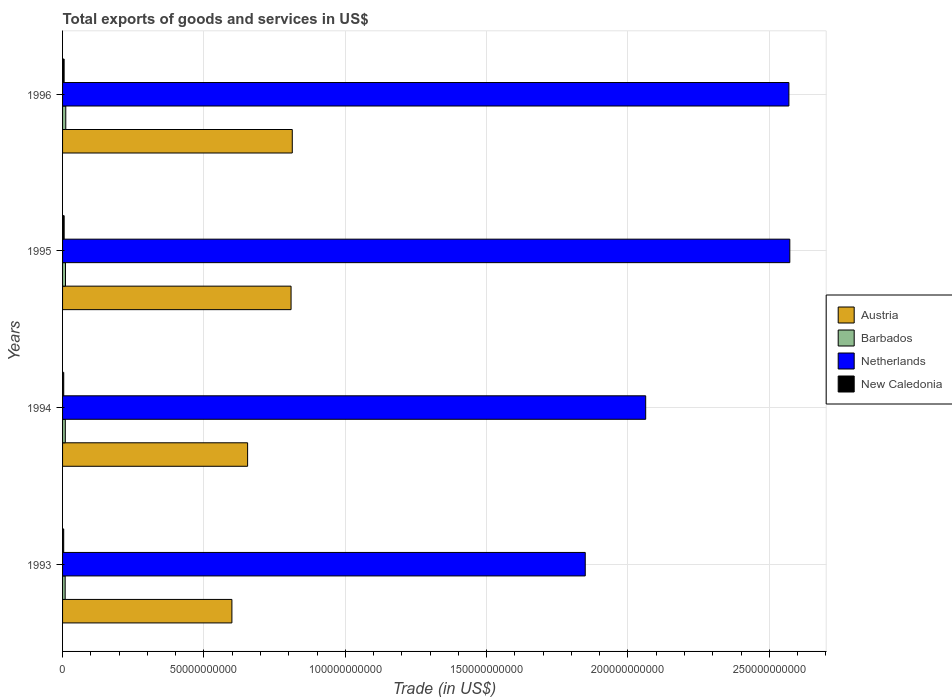Are the number of bars on each tick of the Y-axis equal?
Offer a terse response. Yes. How many bars are there on the 3rd tick from the top?
Your answer should be very brief. 4. What is the label of the 2nd group of bars from the top?
Make the answer very short. 1995. In how many cases, is the number of bars for a given year not equal to the number of legend labels?
Offer a terse response. 0. What is the total exports of goods and services in Netherlands in 1993?
Provide a succinct answer. 1.85e+11. Across all years, what is the maximum total exports of goods and services in Barbados?
Provide a short and direct response. 1.13e+09. Across all years, what is the minimum total exports of goods and services in New Caledonia?
Your answer should be very brief. 4.03e+08. In which year was the total exports of goods and services in New Caledonia maximum?
Your answer should be compact. 1995. In which year was the total exports of goods and services in Netherlands minimum?
Your response must be concise. 1993. What is the total total exports of goods and services in Austria in the graph?
Ensure brevity in your answer.  2.87e+11. What is the difference between the total exports of goods and services in Barbados in 1993 and that in 1995?
Provide a succinct answer. -1.16e+08. What is the difference between the total exports of goods and services in Austria in 1996 and the total exports of goods and services in New Caledonia in 1995?
Your response must be concise. 8.07e+1. What is the average total exports of goods and services in Netherlands per year?
Keep it short and to the point. 2.26e+11. In the year 1996, what is the difference between the total exports of goods and services in Barbados and total exports of goods and services in Austria?
Make the answer very short. -8.01e+1. In how many years, is the total exports of goods and services in Netherlands greater than 20000000000 US$?
Provide a short and direct response. 4. What is the ratio of the total exports of goods and services in New Caledonia in 1994 to that in 1995?
Keep it short and to the point. 0.73. Is the total exports of goods and services in Netherlands in 1993 less than that in 1996?
Your answer should be very brief. Yes. Is the difference between the total exports of goods and services in Barbados in 1994 and 1995 greater than the difference between the total exports of goods and services in Austria in 1994 and 1995?
Offer a terse response. Yes. What is the difference between the highest and the second highest total exports of goods and services in Austria?
Give a very brief answer. 4.29e+08. What is the difference between the highest and the lowest total exports of goods and services in Austria?
Provide a short and direct response. 2.14e+1. In how many years, is the total exports of goods and services in New Caledonia greater than the average total exports of goods and services in New Caledonia taken over all years?
Provide a succinct answer. 2. What does the 1st bar from the top in 1996 represents?
Offer a very short reply. New Caledonia. What does the 2nd bar from the bottom in 1994 represents?
Offer a very short reply. Barbados. How many bars are there?
Your response must be concise. 16. Are all the bars in the graph horizontal?
Your answer should be compact. Yes. How many years are there in the graph?
Your answer should be very brief. 4. Are the values on the major ticks of X-axis written in scientific E-notation?
Your response must be concise. No. Does the graph contain any zero values?
Offer a terse response. No. What is the title of the graph?
Offer a terse response. Total exports of goods and services in US$. What is the label or title of the X-axis?
Give a very brief answer. Trade (in US$). What is the Trade (in US$) in Austria in 1993?
Ensure brevity in your answer.  5.99e+1. What is the Trade (in US$) in Barbados in 1993?
Ensure brevity in your answer.  9.23e+08. What is the Trade (in US$) of Netherlands in 1993?
Make the answer very short. 1.85e+11. What is the Trade (in US$) in New Caledonia in 1993?
Your answer should be very brief. 4.03e+08. What is the Trade (in US$) in Austria in 1994?
Give a very brief answer. 6.55e+1. What is the Trade (in US$) of Barbados in 1994?
Provide a succinct answer. 9.73e+08. What is the Trade (in US$) of Netherlands in 1994?
Make the answer very short. 2.06e+11. What is the Trade (in US$) in New Caledonia in 1994?
Offer a very short reply. 4.13e+08. What is the Trade (in US$) in Austria in 1995?
Your answer should be very brief. 8.08e+1. What is the Trade (in US$) in Barbados in 1995?
Keep it short and to the point. 1.04e+09. What is the Trade (in US$) of Netherlands in 1995?
Your response must be concise. 2.57e+11. What is the Trade (in US$) of New Caledonia in 1995?
Your answer should be compact. 5.65e+08. What is the Trade (in US$) in Austria in 1996?
Your answer should be compact. 8.13e+1. What is the Trade (in US$) in Barbados in 1996?
Your response must be concise. 1.13e+09. What is the Trade (in US$) of Netherlands in 1996?
Your response must be concise. 2.57e+11. What is the Trade (in US$) of New Caledonia in 1996?
Your response must be concise. 5.54e+08. Across all years, what is the maximum Trade (in US$) in Austria?
Your answer should be compact. 8.13e+1. Across all years, what is the maximum Trade (in US$) of Barbados?
Your response must be concise. 1.13e+09. Across all years, what is the maximum Trade (in US$) in Netherlands?
Provide a succinct answer. 2.57e+11. Across all years, what is the maximum Trade (in US$) of New Caledonia?
Your answer should be compact. 5.65e+08. Across all years, what is the minimum Trade (in US$) of Austria?
Provide a succinct answer. 5.99e+1. Across all years, what is the minimum Trade (in US$) of Barbados?
Offer a very short reply. 9.23e+08. Across all years, what is the minimum Trade (in US$) of Netherlands?
Your response must be concise. 1.85e+11. Across all years, what is the minimum Trade (in US$) in New Caledonia?
Your answer should be compact. 4.03e+08. What is the total Trade (in US$) in Austria in the graph?
Offer a terse response. 2.87e+11. What is the total Trade (in US$) in Barbados in the graph?
Provide a short and direct response. 4.07e+09. What is the total Trade (in US$) in Netherlands in the graph?
Provide a succinct answer. 9.05e+11. What is the total Trade (in US$) of New Caledonia in the graph?
Your answer should be compact. 1.93e+09. What is the difference between the Trade (in US$) in Austria in 1993 and that in 1994?
Your response must be concise. -5.55e+09. What is the difference between the Trade (in US$) of Barbados in 1993 and that in 1994?
Make the answer very short. -5.02e+07. What is the difference between the Trade (in US$) in Netherlands in 1993 and that in 1994?
Your response must be concise. -2.14e+1. What is the difference between the Trade (in US$) of New Caledonia in 1993 and that in 1994?
Ensure brevity in your answer.  -1.06e+07. What is the difference between the Trade (in US$) of Austria in 1993 and that in 1995?
Make the answer very short. -2.09e+1. What is the difference between the Trade (in US$) of Barbados in 1993 and that in 1995?
Keep it short and to the point. -1.16e+08. What is the difference between the Trade (in US$) of Netherlands in 1993 and that in 1995?
Keep it short and to the point. -7.24e+1. What is the difference between the Trade (in US$) of New Caledonia in 1993 and that in 1995?
Offer a very short reply. -1.62e+08. What is the difference between the Trade (in US$) of Austria in 1993 and that in 1996?
Your answer should be very brief. -2.14e+1. What is the difference between the Trade (in US$) of Barbados in 1993 and that in 1996?
Give a very brief answer. -2.11e+08. What is the difference between the Trade (in US$) of Netherlands in 1993 and that in 1996?
Provide a succinct answer. -7.20e+1. What is the difference between the Trade (in US$) of New Caledonia in 1993 and that in 1996?
Ensure brevity in your answer.  -1.51e+08. What is the difference between the Trade (in US$) in Austria in 1994 and that in 1995?
Make the answer very short. -1.54e+1. What is the difference between the Trade (in US$) in Barbados in 1994 and that in 1995?
Your answer should be very brief. -6.56e+07. What is the difference between the Trade (in US$) of Netherlands in 1994 and that in 1995?
Provide a succinct answer. -5.10e+1. What is the difference between the Trade (in US$) of New Caledonia in 1994 and that in 1995?
Provide a short and direct response. -1.52e+08. What is the difference between the Trade (in US$) of Austria in 1994 and that in 1996?
Provide a succinct answer. -1.58e+1. What is the difference between the Trade (in US$) in Barbados in 1994 and that in 1996?
Make the answer very short. -1.61e+08. What is the difference between the Trade (in US$) of Netherlands in 1994 and that in 1996?
Keep it short and to the point. -5.07e+1. What is the difference between the Trade (in US$) in New Caledonia in 1994 and that in 1996?
Your response must be concise. -1.40e+08. What is the difference between the Trade (in US$) of Austria in 1995 and that in 1996?
Your response must be concise. -4.29e+08. What is the difference between the Trade (in US$) of Barbados in 1995 and that in 1996?
Make the answer very short. -9.55e+07. What is the difference between the Trade (in US$) of Netherlands in 1995 and that in 1996?
Your response must be concise. 3.20e+08. What is the difference between the Trade (in US$) in New Caledonia in 1995 and that in 1996?
Make the answer very short. 1.12e+07. What is the difference between the Trade (in US$) in Austria in 1993 and the Trade (in US$) in Barbados in 1994?
Offer a terse response. 5.89e+1. What is the difference between the Trade (in US$) of Austria in 1993 and the Trade (in US$) of Netherlands in 1994?
Provide a short and direct response. -1.46e+11. What is the difference between the Trade (in US$) of Austria in 1993 and the Trade (in US$) of New Caledonia in 1994?
Give a very brief answer. 5.95e+1. What is the difference between the Trade (in US$) of Barbados in 1993 and the Trade (in US$) of Netherlands in 1994?
Provide a succinct answer. -2.05e+11. What is the difference between the Trade (in US$) of Barbados in 1993 and the Trade (in US$) of New Caledonia in 1994?
Give a very brief answer. 5.10e+08. What is the difference between the Trade (in US$) of Netherlands in 1993 and the Trade (in US$) of New Caledonia in 1994?
Your answer should be very brief. 1.84e+11. What is the difference between the Trade (in US$) of Austria in 1993 and the Trade (in US$) of Barbados in 1995?
Give a very brief answer. 5.89e+1. What is the difference between the Trade (in US$) of Austria in 1993 and the Trade (in US$) of Netherlands in 1995?
Your answer should be compact. -1.97e+11. What is the difference between the Trade (in US$) of Austria in 1993 and the Trade (in US$) of New Caledonia in 1995?
Offer a terse response. 5.93e+1. What is the difference between the Trade (in US$) in Barbados in 1993 and the Trade (in US$) in Netherlands in 1995?
Provide a succinct answer. -2.56e+11. What is the difference between the Trade (in US$) in Barbados in 1993 and the Trade (in US$) in New Caledonia in 1995?
Keep it short and to the point. 3.59e+08. What is the difference between the Trade (in US$) in Netherlands in 1993 and the Trade (in US$) in New Caledonia in 1995?
Your answer should be very brief. 1.84e+11. What is the difference between the Trade (in US$) of Austria in 1993 and the Trade (in US$) of Barbados in 1996?
Your answer should be compact. 5.88e+1. What is the difference between the Trade (in US$) of Austria in 1993 and the Trade (in US$) of Netherlands in 1996?
Provide a short and direct response. -1.97e+11. What is the difference between the Trade (in US$) of Austria in 1993 and the Trade (in US$) of New Caledonia in 1996?
Give a very brief answer. 5.93e+1. What is the difference between the Trade (in US$) of Barbados in 1993 and the Trade (in US$) of Netherlands in 1996?
Ensure brevity in your answer.  -2.56e+11. What is the difference between the Trade (in US$) of Barbados in 1993 and the Trade (in US$) of New Caledonia in 1996?
Keep it short and to the point. 3.70e+08. What is the difference between the Trade (in US$) in Netherlands in 1993 and the Trade (in US$) in New Caledonia in 1996?
Offer a very short reply. 1.84e+11. What is the difference between the Trade (in US$) in Austria in 1994 and the Trade (in US$) in Barbados in 1995?
Offer a very short reply. 6.44e+1. What is the difference between the Trade (in US$) of Austria in 1994 and the Trade (in US$) of Netherlands in 1995?
Provide a short and direct response. -1.92e+11. What is the difference between the Trade (in US$) of Austria in 1994 and the Trade (in US$) of New Caledonia in 1995?
Your answer should be very brief. 6.49e+1. What is the difference between the Trade (in US$) in Barbados in 1994 and the Trade (in US$) in Netherlands in 1995?
Provide a succinct answer. -2.56e+11. What is the difference between the Trade (in US$) of Barbados in 1994 and the Trade (in US$) of New Caledonia in 1995?
Your answer should be very brief. 4.09e+08. What is the difference between the Trade (in US$) of Netherlands in 1994 and the Trade (in US$) of New Caledonia in 1995?
Your response must be concise. 2.06e+11. What is the difference between the Trade (in US$) of Austria in 1994 and the Trade (in US$) of Barbados in 1996?
Give a very brief answer. 6.43e+1. What is the difference between the Trade (in US$) of Austria in 1994 and the Trade (in US$) of Netherlands in 1996?
Your response must be concise. -1.91e+11. What is the difference between the Trade (in US$) in Austria in 1994 and the Trade (in US$) in New Caledonia in 1996?
Keep it short and to the point. 6.49e+1. What is the difference between the Trade (in US$) in Barbados in 1994 and the Trade (in US$) in Netherlands in 1996?
Keep it short and to the point. -2.56e+11. What is the difference between the Trade (in US$) in Barbados in 1994 and the Trade (in US$) in New Caledonia in 1996?
Give a very brief answer. 4.20e+08. What is the difference between the Trade (in US$) of Netherlands in 1994 and the Trade (in US$) of New Caledonia in 1996?
Your answer should be compact. 2.06e+11. What is the difference between the Trade (in US$) in Austria in 1995 and the Trade (in US$) in Barbados in 1996?
Ensure brevity in your answer.  7.97e+1. What is the difference between the Trade (in US$) of Austria in 1995 and the Trade (in US$) of Netherlands in 1996?
Ensure brevity in your answer.  -1.76e+11. What is the difference between the Trade (in US$) in Austria in 1995 and the Trade (in US$) in New Caledonia in 1996?
Offer a very short reply. 8.03e+1. What is the difference between the Trade (in US$) of Barbados in 1995 and the Trade (in US$) of Netherlands in 1996?
Offer a terse response. -2.56e+11. What is the difference between the Trade (in US$) of Barbados in 1995 and the Trade (in US$) of New Caledonia in 1996?
Offer a very short reply. 4.86e+08. What is the difference between the Trade (in US$) in Netherlands in 1995 and the Trade (in US$) in New Caledonia in 1996?
Give a very brief answer. 2.57e+11. What is the average Trade (in US$) of Austria per year?
Your answer should be very brief. 7.19e+1. What is the average Trade (in US$) in Barbados per year?
Ensure brevity in your answer.  1.02e+09. What is the average Trade (in US$) in Netherlands per year?
Make the answer very short. 2.26e+11. What is the average Trade (in US$) of New Caledonia per year?
Provide a succinct answer. 4.83e+08. In the year 1993, what is the difference between the Trade (in US$) of Austria and Trade (in US$) of Barbados?
Your response must be concise. 5.90e+1. In the year 1993, what is the difference between the Trade (in US$) in Austria and Trade (in US$) in Netherlands?
Make the answer very short. -1.25e+11. In the year 1993, what is the difference between the Trade (in US$) of Austria and Trade (in US$) of New Caledonia?
Offer a very short reply. 5.95e+1. In the year 1993, what is the difference between the Trade (in US$) in Barbados and Trade (in US$) in Netherlands?
Your answer should be compact. -1.84e+11. In the year 1993, what is the difference between the Trade (in US$) in Barbados and Trade (in US$) in New Caledonia?
Ensure brevity in your answer.  5.21e+08. In the year 1993, what is the difference between the Trade (in US$) in Netherlands and Trade (in US$) in New Caledonia?
Ensure brevity in your answer.  1.84e+11. In the year 1994, what is the difference between the Trade (in US$) in Austria and Trade (in US$) in Barbados?
Ensure brevity in your answer.  6.45e+1. In the year 1994, what is the difference between the Trade (in US$) in Austria and Trade (in US$) in Netherlands?
Keep it short and to the point. -1.41e+11. In the year 1994, what is the difference between the Trade (in US$) of Austria and Trade (in US$) of New Caledonia?
Your response must be concise. 6.50e+1. In the year 1994, what is the difference between the Trade (in US$) of Barbados and Trade (in US$) of Netherlands?
Your response must be concise. -2.05e+11. In the year 1994, what is the difference between the Trade (in US$) in Barbados and Trade (in US$) in New Caledonia?
Make the answer very short. 5.60e+08. In the year 1994, what is the difference between the Trade (in US$) of Netherlands and Trade (in US$) of New Caledonia?
Offer a terse response. 2.06e+11. In the year 1995, what is the difference between the Trade (in US$) in Austria and Trade (in US$) in Barbados?
Make the answer very short. 7.98e+1. In the year 1995, what is the difference between the Trade (in US$) of Austria and Trade (in US$) of Netherlands?
Your answer should be very brief. -1.76e+11. In the year 1995, what is the difference between the Trade (in US$) in Austria and Trade (in US$) in New Caledonia?
Ensure brevity in your answer.  8.03e+1. In the year 1995, what is the difference between the Trade (in US$) of Barbados and Trade (in US$) of Netherlands?
Your answer should be very brief. -2.56e+11. In the year 1995, what is the difference between the Trade (in US$) in Barbados and Trade (in US$) in New Caledonia?
Offer a very short reply. 4.74e+08. In the year 1995, what is the difference between the Trade (in US$) in Netherlands and Trade (in US$) in New Caledonia?
Your answer should be compact. 2.57e+11. In the year 1996, what is the difference between the Trade (in US$) of Austria and Trade (in US$) of Barbados?
Provide a short and direct response. 8.01e+1. In the year 1996, what is the difference between the Trade (in US$) in Austria and Trade (in US$) in Netherlands?
Provide a succinct answer. -1.76e+11. In the year 1996, what is the difference between the Trade (in US$) in Austria and Trade (in US$) in New Caledonia?
Give a very brief answer. 8.07e+1. In the year 1996, what is the difference between the Trade (in US$) in Barbados and Trade (in US$) in Netherlands?
Offer a terse response. -2.56e+11. In the year 1996, what is the difference between the Trade (in US$) in Barbados and Trade (in US$) in New Caledonia?
Offer a very short reply. 5.81e+08. In the year 1996, what is the difference between the Trade (in US$) of Netherlands and Trade (in US$) of New Caledonia?
Your answer should be very brief. 2.56e+11. What is the ratio of the Trade (in US$) in Austria in 1993 to that in 1994?
Make the answer very short. 0.92. What is the ratio of the Trade (in US$) of Barbados in 1993 to that in 1994?
Offer a terse response. 0.95. What is the ratio of the Trade (in US$) in Netherlands in 1993 to that in 1994?
Provide a succinct answer. 0.9. What is the ratio of the Trade (in US$) in New Caledonia in 1993 to that in 1994?
Your answer should be very brief. 0.97. What is the ratio of the Trade (in US$) in Austria in 1993 to that in 1995?
Your answer should be very brief. 0.74. What is the ratio of the Trade (in US$) of Barbados in 1993 to that in 1995?
Your answer should be very brief. 0.89. What is the ratio of the Trade (in US$) of Netherlands in 1993 to that in 1995?
Ensure brevity in your answer.  0.72. What is the ratio of the Trade (in US$) of New Caledonia in 1993 to that in 1995?
Provide a short and direct response. 0.71. What is the ratio of the Trade (in US$) of Austria in 1993 to that in 1996?
Give a very brief answer. 0.74. What is the ratio of the Trade (in US$) of Barbados in 1993 to that in 1996?
Your answer should be very brief. 0.81. What is the ratio of the Trade (in US$) in Netherlands in 1993 to that in 1996?
Give a very brief answer. 0.72. What is the ratio of the Trade (in US$) in New Caledonia in 1993 to that in 1996?
Ensure brevity in your answer.  0.73. What is the ratio of the Trade (in US$) of Austria in 1994 to that in 1995?
Keep it short and to the point. 0.81. What is the ratio of the Trade (in US$) of Barbados in 1994 to that in 1995?
Keep it short and to the point. 0.94. What is the ratio of the Trade (in US$) of Netherlands in 1994 to that in 1995?
Your answer should be very brief. 0.8. What is the ratio of the Trade (in US$) in New Caledonia in 1994 to that in 1995?
Offer a very short reply. 0.73. What is the ratio of the Trade (in US$) of Austria in 1994 to that in 1996?
Offer a terse response. 0.81. What is the ratio of the Trade (in US$) in Barbados in 1994 to that in 1996?
Provide a short and direct response. 0.86. What is the ratio of the Trade (in US$) in Netherlands in 1994 to that in 1996?
Ensure brevity in your answer.  0.8. What is the ratio of the Trade (in US$) of New Caledonia in 1994 to that in 1996?
Offer a terse response. 0.75. What is the ratio of the Trade (in US$) in Austria in 1995 to that in 1996?
Make the answer very short. 0.99. What is the ratio of the Trade (in US$) in Barbados in 1995 to that in 1996?
Provide a succinct answer. 0.92. What is the ratio of the Trade (in US$) of New Caledonia in 1995 to that in 1996?
Your answer should be compact. 1.02. What is the difference between the highest and the second highest Trade (in US$) of Austria?
Ensure brevity in your answer.  4.29e+08. What is the difference between the highest and the second highest Trade (in US$) in Barbados?
Keep it short and to the point. 9.55e+07. What is the difference between the highest and the second highest Trade (in US$) of Netherlands?
Offer a terse response. 3.20e+08. What is the difference between the highest and the second highest Trade (in US$) in New Caledonia?
Your answer should be very brief. 1.12e+07. What is the difference between the highest and the lowest Trade (in US$) in Austria?
Your response must be concise. 2.14e+1. What is the difference between the highest and the lowest Trade (in US$) of Barbados?
Make the answer very short. 2.11e+08. What is the difference between the highest and the lowest Trade (in US$) of Netherlands?
Keep it short and to the point. 7.24e+1. What is the difference between the highest and the lowest Trade (in US$) of New Caledonia?
Make the answer very short. 1.62e+08. 